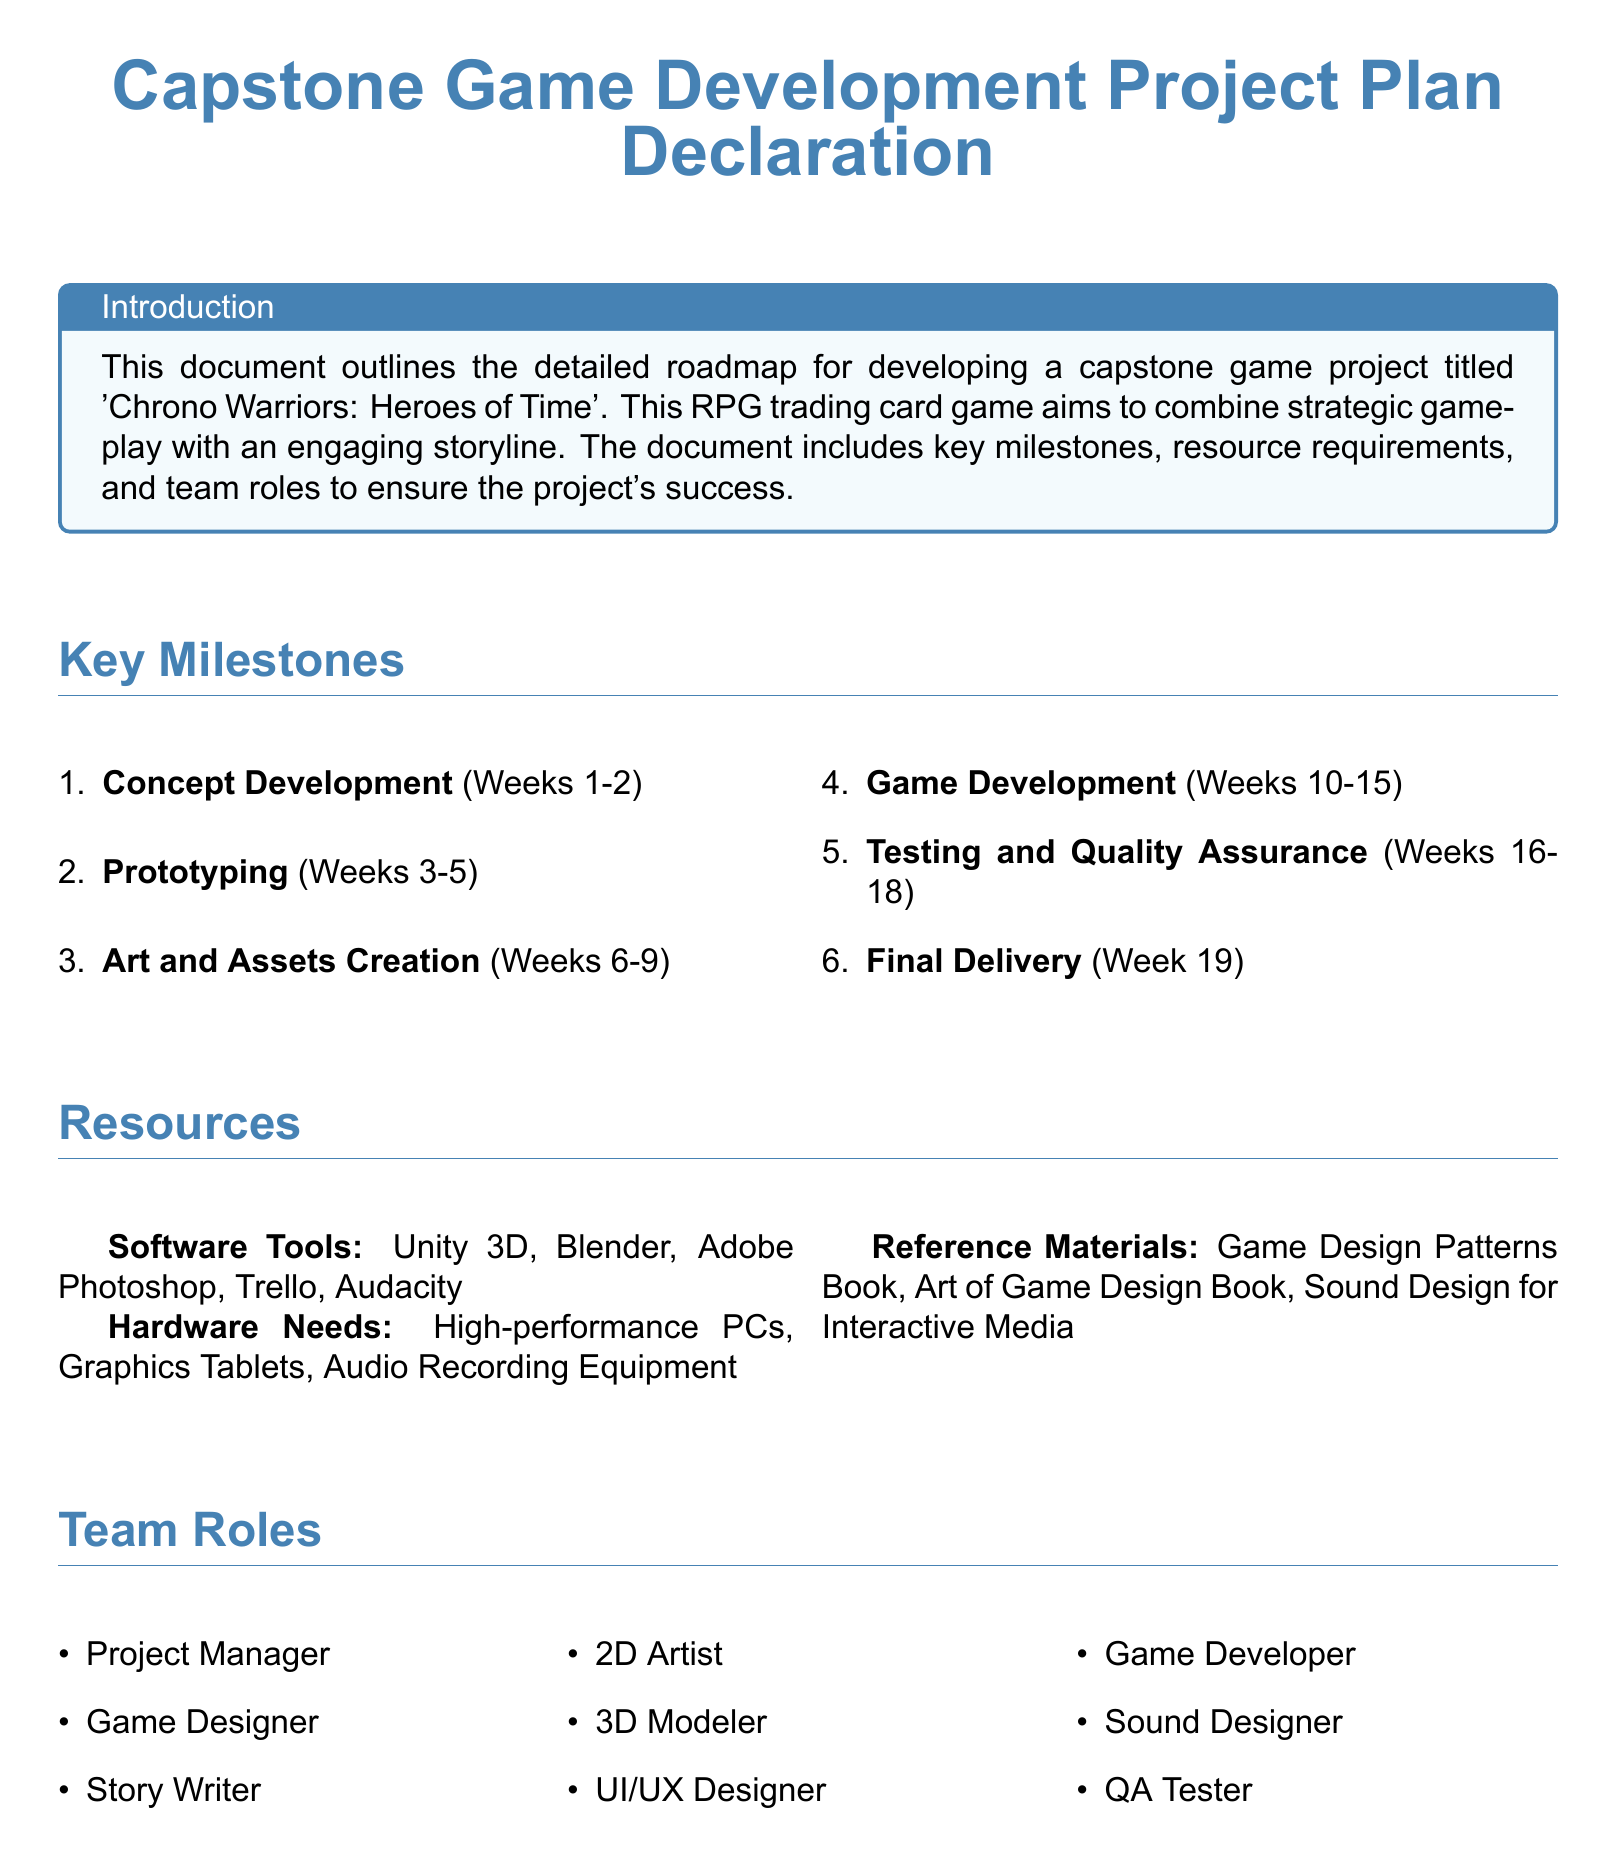What is the title of the game project? The title of the game project is stated at the beginning of the document and is 'Chrono Warriors: Heroes of Time'.
Answer: Chrono Warriors: Heroes of Time How many weeks are allocated for testing and quality assurance? The document specifies that testing and quality assurance will take place over a period of 3 weeks, from Weeks 16 to 18.
Answer: 3 weeks Which software tool is used for game development? The document lists several software tools, and Unity 3D is specified as the tool for game development.
Answer: Unity 3D Who is responsible for creating the game's narrative? The document outlines roles and mentions that the Story Writer is responsible for creating the game's narrative.
Answer: Story Writer What is the milestone following prototyping? The document lists the milestones in order, and the one following prototyping is Art and Assets Creation.
Answer: Art and Assets Creation How many team roles are listed in the document? By enumerating the team roles stated in the document, it is clear that there are nine distinct roles mentioned.
Answer: Nine roles What is the main objective of the capstone game project? The introduction section outlines the main objective of combining strategic gameplay with an engaging storyline.
Answer: Strategic gameplay with an engaging storyline What is the final milestone before project delivery? The document specifies that the final milestone before project delivery is Testing and Quality Assurance.
Answer: Testing and Quality Assurance Who declares commitment to the project? The declaration section indicates that the college student majoring in game design makes the commitment.
Answer: College student 